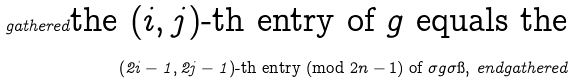Convert formula to latex. <formula><loc_0><loc_0><loc_500><loc_500>\ g a t h e r e d \text {the $(i,j)$-th entry of $g$ equals the} \\ ( 2 i - 1 , 2 j - 1 ) \text {-th entry (mod $2n-1$) of $\sigma g \sigma\i$,} \ e n d g a t h e r e d</formula> 